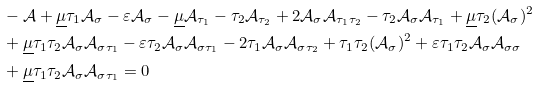Convert formula to latex. <formula><loc_0><loc_0><loc_500><loc_500>& - { \mathcal { A } } + \underline { \mu } \tau _ { 1 } { \mathcal { A } } _ { \sigma } - \varepsilon { \mathcal { A } } _ { \sigma } - \underline { \mu } { \mathcal { A } } _ { \tau _ { 1 } } - \tau _ { 2 } { \mathcal { A } } _ { \tau _ { 2 } } + 2 { \mathcal { A } } _ { \sigma } { \mathcal { A } } _ { \tau _ { 1 } \tau _ { 2 } } - \tau _ { 2 } { \mathcal { A } } _ { \sigma } { \mathcal { A } } _ { \tau _ { 1 } } + \underline { \mu } \tau _ { 2 } ( { \mathcal { A } } _ { \sigma } ) ^ { 2 } \\ & + \underline { \mu } \tau _ { 1 } \tau _ { 2 } { \mathcal { A } } _ { \sigma } { \mathcal { A } } _ { \sigma \tau _ { 1 } } - \varepsilon \tau _ { 2 } { \mathcal { A } } _ { \sigma } { \mathcal { A } } _ { \sigma \tau _ { 1 } } - 2 \tau _ { 1 } { \mathcal { A } } _ { \sigma } { \mathcal { A } } _ { \sigma \tau _ { 2 } } + \tau _ { 1 } \tau _ { 2 } ( { \mathcal { A } } _ { \sigma } ) ^ { 2 } + \varepsilon \tau _ { 1 } \tau _ { 2 } { \mathcal { A } } _ { \sigma } { \mathcal { A } } _ { \sigma \sigma } \\ & + \underline { \mu } \tau _ { 1 } \tau _ { 2 } { \mathcal { A } } _ { \sigma } { \mathcal { A } } _ { \sigma \tau _ { 1 } } = 0</formula> 